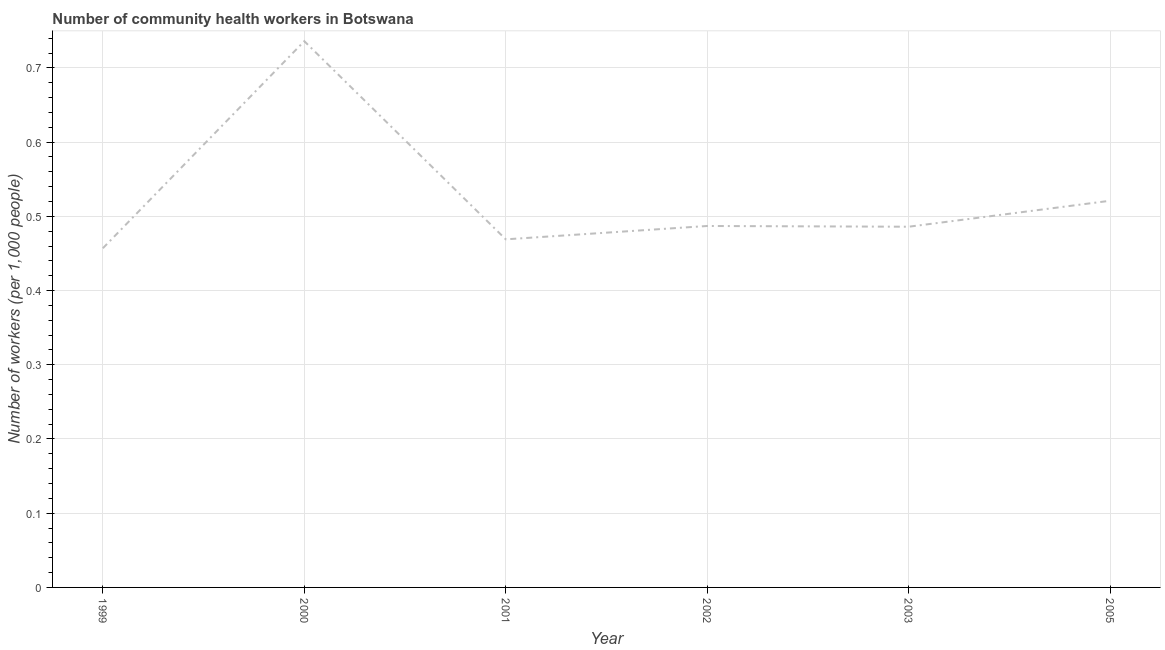What is the number of community health workers in 2001?
Offer a very short reply. 0.47. Across all years, what is the maximum number of community health workers?
Give a very brief answer. 0.74. Across all years, what is the minimum number of community health workers?
Provide a succinct answer. 0.46. What is the sum of the number of community health workers?
Your response must be concise. 3.16. What is the difference between the number of community health workers in 2000 and 2002?
Make the answer very short. 0.25. What is the average number of community health workers per year?
Offer a very short reply. 0.53. What is the median number of community health workers?
Make the answer very short. 0.49. In how many years, is the number of community health workers greater than 0.7000000000000001 ?
Your response must be concise. 1. Do a majority of the years between 2001 and 2005 (inclusive) have number of community health workers greater than 0.12000000000000001 ?
Provide a short and direct response. Yes. What is the ratio of the number of community health workers in 2000 to that in 2005?
Make the answer very short. 1.41. What is the difference between the highest and the second highest number of community health workers?
Your answer should be compact. 0.21. Is the sum of the number of community health workers in 2002 and 2005 greater than the maximum number of community health workers across all years?
Your answer should be compact. Yes. What is the difference between the highest and the lowest number of community health workers?
Give a very brief answer. 0.28. In how many years, is the number of community health workers greater than the average number of community health workers taken over all years?
Your answer should be compact. 1. Does the number of community health workers monotonically increase over the years?
Give a very brief answer. No. How many lines are there?
Provide a short and direct response. 1. Are the values on the major ticks of Y-axis written in scientific E-notation?
Your response must be concise. No. Does the graph contain grids?
Your answer should be compact. Yes. What is the title of the graph?
Provide a short and direct response. Number of community health workers in Botswana. What is the label or title of the Y-axis?
Ensure brevity in your answer.  Number of workers (per 1,0 people). What is the Number of workers (per 1,000 people) of 1999?
Make the answer very short. 0.46. What is the Number of workers (per 1,000 people) of 2000?
Make the answer very short. 0.74. What is the Number of workers (per 1,000 people) of 2001?
Provide a succinct answer. 0.47. What is the Number of workers (per 1,000 people) in 2002?
Keep it short and to the point. 0.49. What is the Number of workers (per 1,000 people) in 2003?
Your answer should be compact. 0.49. What is the Number of workers (per 1,000 people) of 2005?
Provide a succinct answer. 0.52. What is the difference between the Number of workers (per 1,000 people) in 1999 and 2000?
Ensure brevity in your answer.  -0.28. What is the difference between the Number of workers (per 1,000 people) in 1999 and 2001?
Provide a succinct answer. -0.01. What is the difference between the Number of workers (per 1,000 people) in 1999 and 2002?
Offer a terse response. -0.03. What is the difference between the Number of workers (per 1,000 people) in 1999 and 2003?
Make the answer very short. -0.03. What is the difference between the Number of workers (per 1,000 people) in 1999 and 2005?
Your answer should be compact. -0.06. What is the difference between the Number of workers (per 1,000 people) in 2000 and 2001?
Keep it short and to the point. 0.27. What is the difference between the Number of workers (per 1,000 people) in 2000 and 2002?
Your response must be concise. 0.25. What is the difference between the Number of workers (per 1,000 people) in 2000 and 2003?
Keep it short and to the point. 0.25. What is the difference between the Number of workers (per 1,000 people) in 2000 and 2005?
Ensure brevity in your answer.  0.21. What is the difference between the Number of workers (per 1,000 people) in 2001 and 2002?
Your answer should be very brief. -0.02. What is the difference between the Number of workers (per 1,000 people) in 2001 and 2003?
Provide a succinct answer. -0.02. What is the difference between the Number of workers (per 1,000 people) in 2001 and 2005?
Give a very brief answer. -0.05. What is the difference between the Number of workers (per 1,000 people) in 2002 and 2003?
Your response must be concise. 0. What is the difference between the Number of workers (per 1,000 people) in 2002 and 2005?
Your answer should be compact. -0.03. What is the difference between the Number of workers (per 1,000 people) in 2003 and 2005?
Offer a terse response. -0.04. What is the ratio of the Number of workers (per 1,000 people) in 1999 to that in 2000?
Provide a succinct answer. 0.62. What is the ratio of the Number of workers (per 1,000 people) in 1999 to that in 2001?
Give a very brief answer. 0.97. What is the ratio of the Number of workers (per 1,000 people) in 1999 to that in 2002?
Provide a succinct answer. 0.94. What is the ratio of the Number of workers (per 1,000 people) in 1999 to that in 2003?
Keep it short and to the point. 0.94. What is the ratio of the Number of workers (per 1,000 people) in 1999 to that in 2005?
Ensure brevity in your answer.  0.88. What is the ratio of the Number of workers (per 1,000 people) in 2000 to that in 2001?
Ensure brevity in your answer.  1.57. What is the ratio of the Number of workers (per 1,000 people) in 2000 to that in 2002?
Offer a terse response. 1.51. What is the ratio of the Number of workers (per 1,000 people) in 2000 to that in 2003?
Provide a succinct answer. 1.51. What is the ratio of the Number of workers (per 1,000 people) in 2000 to that in 2005?
Make the answer very short. 1.41. What is the ratio of the Number of workers (per 1,000 people) in 2001 to that in 2002?
Keep it short and to the point. 0.96. What is the ratio of the Number of workers (per 1,000 people) in 2001 to that in 2005?
Ensure brevity in your answer.  0.9. What is the ratio of the Number of workers (per 1,000 people) in 2002 to that in 2005?
Offer a terse response. 0.94. What is the ratio of the Number of workers (per 1,000 people) in 2003 to that in 2005?
Provide a succinct answer. 0.93. 